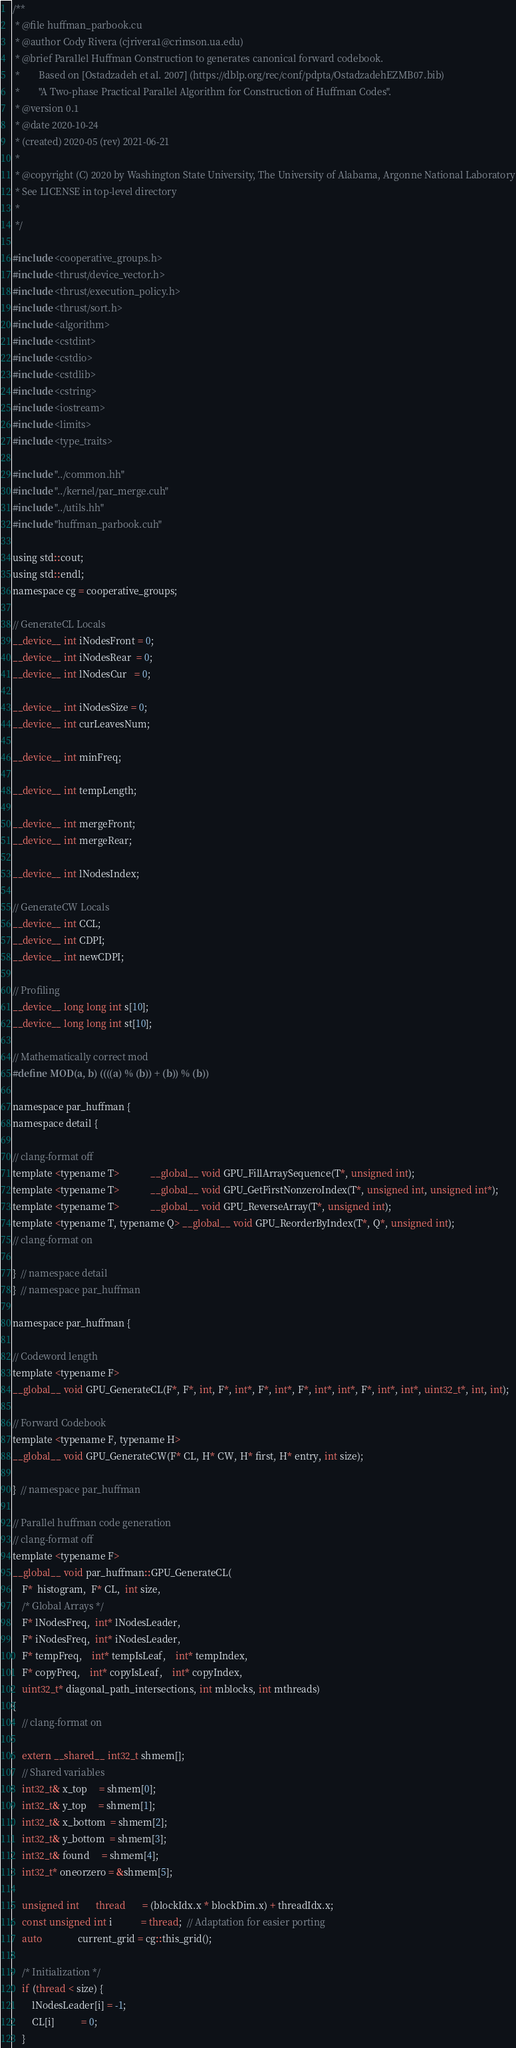<code> <loc_0><loc_0><loc_500><loc_500><_Cuda_>/**
 * @file huffman_parbook.cu
 * @author Cody Rivera (cjrivera1@crimson.ua.edu)
 * @brief Parallel Huffman Construction to generates canonical forward codebook.
 *        Based on [Ostadzadeh et al. 2007] (https://dblp.org/rec/conf/pdpta/OstadzadehEZMB07.bib)
 *        "A Two-phase Practical Parallel Algorithm for Construction of Huffman Codes".
 * @version 0.1
 * @date 2020-10-24
 * (created) 2020-05 (rev) 2021-06-21
 *
 * @copyright (C) 2020 by Washington State University, The University of Alabama, Argonne National Laboratory
 * See LICENSE in top-level directory
 *
 */

#include <cooperative_groups.h>
#include <thrust/device_vector.h>
#include <thrust/execution_policy.h>
#include <thrust/sort.h>
#include <algorithm>
#include <cstdint>
#include <cstdio>
#include <cstdlib>
#include <cstring>
#include <iostream>
#include <limits>
#include <type_traits>

#include "../common.hh"
#include "../kernel/par_merge.cuh"
#include "../utils.hh"
#include "huffman_parbook.cuh"

using std::cout;
using std::endl;
namespace cg = cooperative_groups;

// GenerateCL Locals
__device__ int iNodesFront = 0;
__device__ int iNodesRear  = 0;
__device__ int lNodesCur   = 0;

__device__ int iNodesSize = 0;
__device__ int curLeavesNum;

__device__ int minFreq;

__device__ int tempLength;

__device__ int mergeFront;
__device__ int mergeRear;

__device__ int lNodesIndex;

// GenerateCW Locals
__device__ int CCL;
__device__ int CDPI;
__device__ int newCDPI;

// Profiling
__device__ long long int s[10];
__device__ long long int st[10];

// Mathematically correct mod
#define MOD(a, b) ((((a) % (b)) + (b)) % (b))

namespace par_huffman {
namespace detail {

// clang-format off
template <typename T>             __global__ void GPU_FillArraySequence(T*, unsigned int);
template <typename T>             __global__ void GPU_GetFirstNonzeroIndex(T*, unsigned int, unsigned int*);
template <typename T>             __global__ void GPU_ReverseArray(T*, unsigned int);
template <typename T, typename Q> __global__ void GPU_ReorderByIndex(T*, Q*, unsigned int);
// clang-format on

}  // namespace detail
}  // namespace par_huffman

namespace par_huffman {

// Codeword length
template <typename F>
__global__ void GPU_GenerateCL(F*, F*, int, F*, int*, F*, int*, F*, int*, int*, F*, int*, int*, uint32_t*, int, int);

// Forward Codebook
template <typename F, typename H>
__global__ void GPU_GenerateCW(F* CL, H* CW, H* first, H* entry, int size);

}  // namespace par_huffman

// Parallel huffman code generation
// clang-format off
template <typename F>
__global__ void par_huffman::GPU_GenerateCL(
    F*  histogram,  F* CL,  int size,
    /* Global Arrays */
    F* lNodesFreq,  int* lNodesLeader,
    F* iNodesFreq,  int* iNodesLeader,
    F* tempFreq,    int* tempIsLeaf,    int* tempIndex,
    F* copyFreq,    int* copyIsLeaf,    int* copyIndex,
    uint32_t* diagonal_path_intersections, int mblocks, int mthreads)
{
    // clang-format on

    extern __shared__ int32_t shmem[];
    // Shared variables
    int32_t& x_top     = shmem[0];
    int32_t& y_top     = shmem[1];
    int32_t& x_bottom  = shmem[2];
    int32_t& y_bottom  = shmem[3];
    int32_t& found     = shmem[4];
    int32_t* oneorzero = &shmem[5];

    unsigned int       thread       = (blockIdx.x * blockDim.x) + threadIdx.x;
    const unsigned int i            = thread;  // Adaptation for easier porting
    auto               current_grid = cg::this_grid();

    /* Initialization */
    if (thread < size) {
        lNodesLeader[i] = -1;
        CL[i]           = 0;
    }
</code> 